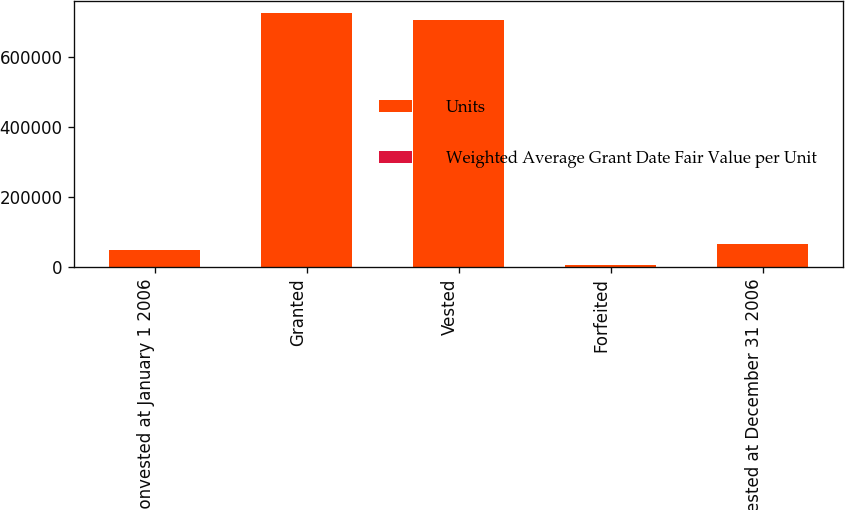<chart> <loc_0><loc_0><loc_500><loc_500><stacked_bar_chart><ecel><fcel>Nonvested at January 1 2006<fcel>Granted<fcel>Vested<fcel>Forfeited<fcel>Nonvested at December 31 2006<nl><fcel>Units<fcel>49395<fcel>724554<fcel>704385<fcel>5092<fcel>64472<nl><fcel>Weighted Average Grant Date Fair Value per Unit<fcel>24.67<fcel>24<fcel>23.99<fcel>25.36<fcel>24.51<nl></chart> 